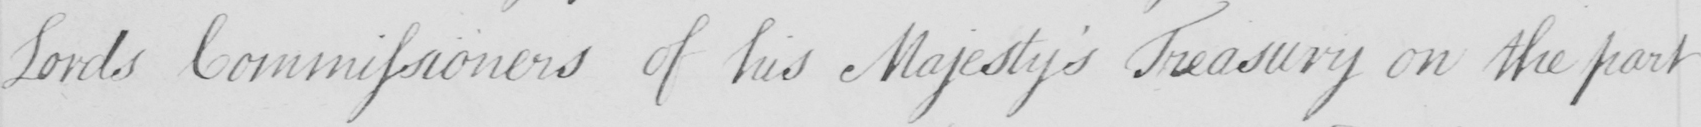What text is written in this handwritten line? Lords Commissioners of his Majesty ' s Treasury on the part 